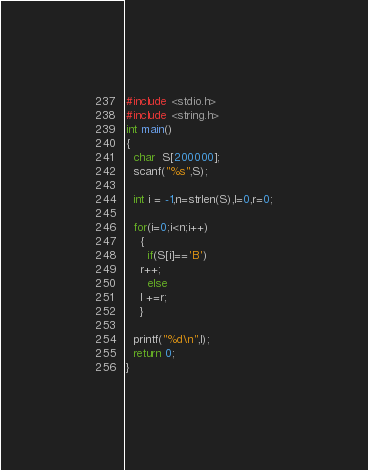<code> <loc_0><loc_0><loc_500><loc_500><_C_>#include <stdio.h>
#include <string.h>
int main()
{
  char  S[200000];
  scanf("%s",S);

  int i = -1,n=strlen(S),l=0,r=0;
 
  for(i=0;i<n;i++)
    {
      if(S[i]=='B')
	r++;
      else
	l +=r;
    }
  
  printf("%d\n",l);
  return 0;
}
</code> 